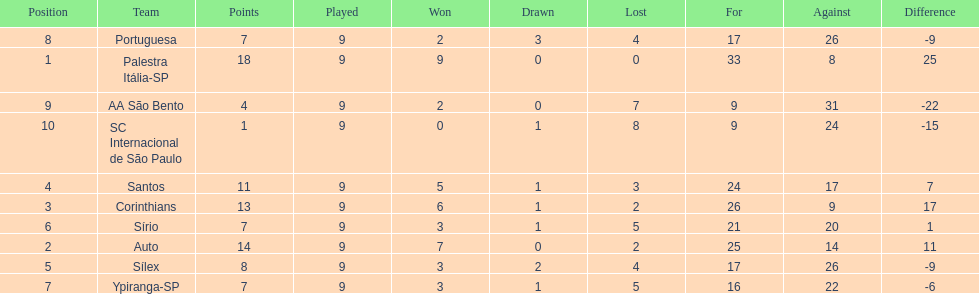Which is the only team to score 13 points in 9 games? Corinthians. 